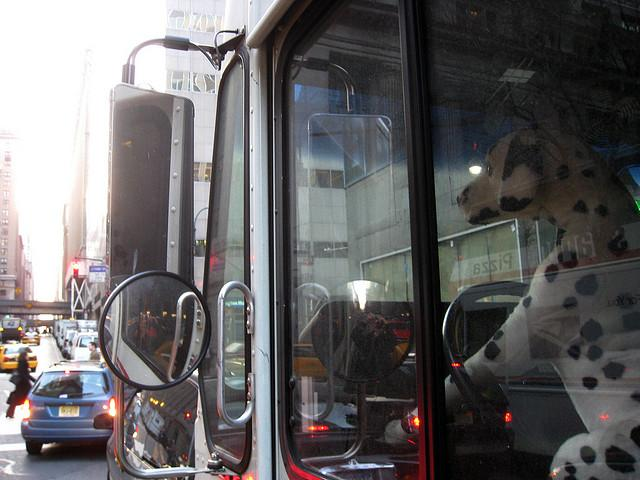Which lens is used in bus side mirror? Please explain your reasoning. convex. The convex lens is used in the mirror. 